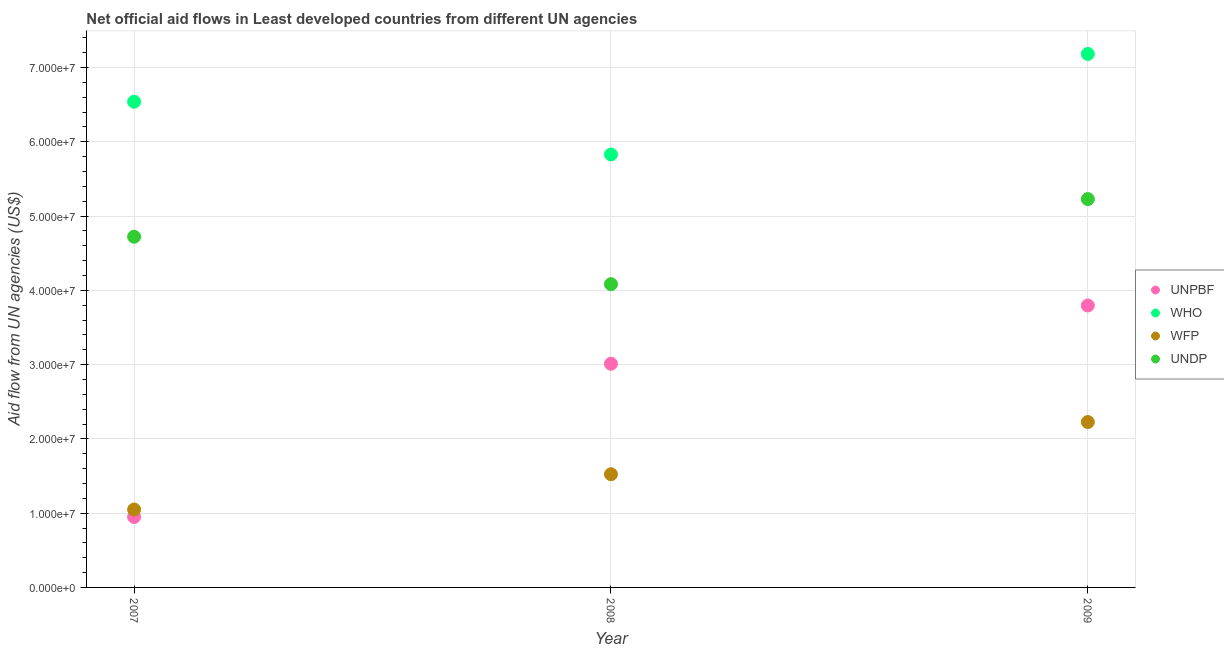Is the number of dotlines equal to the number of legend labels?
Give a very brief answer. Yes. What is the amount of aid given by undp in 2007?
Offer a terse response. 4.72e+07. Across all years, what is the maximum amount of aid given by undp?
Your response must be concise. 5.23e+07. Across all years, what is the minimum amount of aid given by undp?
Your answer should be very brief. 4.08e+07. In which year was the amount of aid given by unpbf maximum?
Ensure brevity in your answer.  2009. In which year was the amount of aid given by unpbf minimum?
Offer a very short reply. 2007. What is the total amount of aid given by wfp in the graph?
Your response must be concise. 4.80e+07. What is the difference between the amount of aid given by undp in 2007 and that in 2009?
Provide a succinct answer. -5.07e+06. What is the difference between the amount of aid given by who in 2007 and the amount of aid given by wfp in 2008?
Your answer should be very brief. 5.02e+07. What is the average amount of aid given by unpbf per year?
Provide a succinct answer. 2.59e+07. In the year 2009, what is the difference between the amount of aid given by wfp and amount of aid given by undp?
Offer a terse response. -3.00e+07. What is the ratio of the amount of aid given by who in 2007 to that in 2008?
Keep it short and to the point. 1.12. Is the difference between the amount of aid given by who in 2007 and 2009 greater than the difference between the amount of aid given by unpbf in 2007 and 2009?
Keep it short and to the point. Yes. What is the difference between the highest and the second highest amount of aid given by unpbf?
Provide a short and direct response. 7.84e+06. What is the difference between the highest and the lowest amount of aid given by wfp?
Offer a very short reply. 1.18e+07. In how many years, is the amount of aid given by who greater than the average amount of aid given by who taken over all years?
Your response must be concise. 2. Is the sum of the amount of aid given by wfp in 2008 and 2009 greater than the maximum amount of aid given by undp across all years?
Your answer should be compact. No. Is it the case that in every year, the sum of the amount of aid given by unpbf and amount of aid given by undp is greater than the sum of amount of aid given by who and amount of aid given by wfp?
Offer a terse response. Yes. How many dotlines are there?
Keep it short and to the point. 4. Are the values on the major ticks of Y-axis written in scientific E-notation?
Your response must be concise. Yes. Does the graph contain any zero values?
Your response must be concise. No. Does the graph contain grids?
Offer a very short reply. Yes. How are the legend labels stacked?
Your answer should be very brief. Vertical. What is the title of the graph?
Keep it short and to the point. Net official aid flows in Least developed countries from different UN agencies. What is the label or title of the Y-axis?
Provide a succinct answer. Aid flow from UN agencies (US$). What is the Aid flow from UN agencies (US$) in UNPBF in 2007?
Give a very brief answer. 9.49e+06. What is the Aid flow from UN agencies (US$) in WHO in 2007?
Provide a short and direct response. 6.54e+07. What is the Aid flow from UN agencies (US$) in WFP in 2007?
Provide a short and direct response. 1.05e+07. What is the Aid flow from UN agencies (US$) of UNDP in 2007?
Offer a very short reply. 4.72e+07. What is the Aid flow from UN agencies (US$) of UNPBF in 2008?
Ensure brevity in your answer.  3.01e+07. What is the Aid flow from UN agencies (US$) of WHO in 2008?
Offer a terse response. 5.83e+07. What is the Aid flow from UN agencies (US$) of WFP in 2008?
Your answer should be very brief. 1.52e+07. What is the Aid flow from UN agencies (US$) in UNDP in 2008?
Offer a terse response. 4.08e+07. What is the Aid flow from UN agencies (US$) of UNPBF in 2009?
Give a very brief answer. 3.80e+07. What is the Aid flow from UN agencies (US$) of WHO in 2009?
Your answer should be very brief. 7.18e+07. What is the Aid flow from UN agencies (US$) in WFP in 2009?
Keep it short and to the point. 2.23e+07. What is the Aid flow from UN agencies (US$) of UNDP in 2009?
Keep it short and to the point. 5.23e+07. Across all years, what is the maximum Aid flow from UN agencies (US$) in UNPBF?
Provide a short and direct response. 3.80e+07. Across all years, what is the maximum Aid flow from UN agencies (US$) of WHO?
Ensure brevity in your answer.  7.18e+07. Across all years, what is the maximum Aid flow from UN agencies (US$) of WFP?
Keep it short and to the point. 2.23e+07. Across all years, what is the maximum Aid flow from UN agencies (US$) in UNDP?
Offer a very short reply. 5.23e+07. Across all years, what is the minimum Aid flow from UN agencies (US$) of UNPBF?
Provide a short and direct response. 9.49e+06. Across all years, what is the minimum Aid flow from UN agencies (US$) in WHO?
Your answer should be very brief. 5.83e+07. Across all years, what is the minimum Aid flow from UN agencies (US$) in WFP?
Your response must be concise. 1.05e+07. Across all years, what is the minimum Aid flow from UN agencies (US$) of UNDP?
Your answer should be very brief. 4.08e+07. What is the total Aid flow from UN agencies (US$) of UNPBF in the graph?
Make the answer very short. 7.76e+07. What is the total Aid flow from UN agencies (US$) in WHO in the graph?
Offer a very short reply. 1.96e+08. What is the total Aid flow from UN agencies (US$) in WFP in the graph?
Your response must be concise. 4.80e+07. What is the total Aid flow from UN agencies (US$) in UNDP in the graph?
Your response must be concise. 1.40e+08. What is the difference between the Aid flow from UN agencies (US$) in UNPBF in 2007 and that in 2008?
Ensure brevity in your answer.  -2.06e+07. What is the difference between the Aid flow from UN agencies (US$) of WHO in 2007 and that in 2008?
Provide a succinct answer. 7.10e+06. What is the difference between the Aid flow from UN agencies (US$) of WFP in 2007 and that in 2008?
Your answer should be compact. -4.75e+06. What is the difference between the Aid flow from UN agencies (US$) of UNDP in 2007 and that in 2008?
Your answer should be compact. 6.39e+06. What is the difference between the Aid flow from UN agencies (US$) in UNPBF in 2007 and that in 2009?
Provide a short and direct response. -2.85e+07. What is the difference between the Aid flow from UN agencies (US$) of WHO in 2007 and that in 2009?
Make the answer very short. -6.43e+06. What is the difference between the Aid flow from UN agencies (US$) in WFP in 2007 and that in 2009?
Give a very brief answer. -1.18e+07. What is the difference between the Aid flow from UN agencies (US$) in UNDP in 2007 and that in 2009?
Offer a terse response. -5.07e+06. What is the difference between the Aid flow from UN agencies (US$) in UNPBF in 2008 and that in 2009?
Give a very brief answer. -7.84e+06. What is the difference between the Aid flow from UN agencies (US$) of WHO in 2008 and that in 2009?
Provide a short and direct response. -1.35e+07. What is the difference between the Aid flow from UN agencies (US$) of WFP in 2008 and that in 2009?
Make the answer very short. -7.03e+06. What is the difference between the Aid flow from UN agencies (US$) in UNDP in 2008 and that in 2009?
Provide a succinct answer. -1.15e+07. What is the difference between the Aid flow from UN agencies (US$) in UNPBF in 2007 and the Aid flow from UN agencies (US$) in WHO in 2008?
Provide a short and direct response. -4.88e+07. What is the difference between the Aid flow from UN agencies (US$) of UNPBF in 2007 and the Aid flow from UN agencies (US$) of WFP in 2008?
Your answer should be compact. -5.75e+06. What is the difference between the Aid flow from UN agencies (US$) in UNPBF in 2007 and the Aid flow from UN agencies (US$) in UNDP in 2008?
Your answer should be very brief. -3.13e+07. What is the difference between the Aid flow from UN agencies (US$) of WHO in 2007 and the Aid flow from UN agencies (US$) of WFP in 2008?
Your answer should be very brief. 5.02e+07. What is the difference between the Aid flow from UN agencies (US$) in WHO in 2007 and the Aid flow from UN agencies (US$) in UNDP in 2008?
Your answer should be very brief. 2.46e+07. What is the difference between the Aid flow from UN agencies (US$) of WFP in 2007 and the Aid flow from UN agencies (US$) of UNDP in 2008?
Your response must be concise. -3.03e+07. What is the difference between the Aid flow from UN agencies (US$) of UNPBF in 2007 and the Aid flow from UN agencies (US$) of WHO in 2009?
Give a very brief answer. -6.23e+07. What is the difference between the Aid flow from UN agencies (US$) in UNPBF in 2007 and the Aid flow from UN agencies (US$) in WFP in 2009?
Give a very brief answer. -1.28e+07. What is the difference between the Aid flow from UN agencies (US$) in UNPBF in 2007 and the Aid flow from UN agencies (US$) in UNDP in 2009?
Your answer should be compact. -4.28e+07. What is the difference between the Aid flow from UN agencies (US$) of WHO in 2007 and the Aid flow from UN agencies (US$) of WFP in 2009?
Provide a succinct answer. 4.31e+07. What is the difference between the Aid flow from UN agencies (US$) in WHO in 2007 and the Aid flow from UN agencies (US$) in UNDP in 2009?
Keep it short and to the point. 1.31e+07. What is the difference between the Aid flow from UN agencies (US$) in WFP in 2007 and the Aid flow from UN agencies (US$) in UNDP in 2009?
Your answer should be compact. -4.18e+07. What is the difference between the Aid flow from UN agencies (US$) of UNPBF in 2008 and the Aid flow from UN agencies (US$) of WHO in 2009?
Make the answer very short. -4.17e+07. What is the difference between the Aid flow from UN agencies (US$) of UNPBF in 2008 and the Aid flow from UN agencies (US$) of WFP in 2009?
Give a very brief answer. 7.85e+06. What is the difference between the Aid flow from UN agencies (US$) of UNPBF in 2008 and the Aid flow from UN agencies (US$) of UNDP in 2009?
Your response must be concise. -2.22e+07. What is the difference between the Aid flow from UN agencies (US$) in WHO in 2008 and the Aid flow from UN agencies (US$) in WFP in 2009?
Ensure brevity in your answer.  3.60e+07. What is the difference between the Aid flow from UN agencies (US$) of WHO in 2008 and the Aid flow from UN agencies (US$) of UNDP in 2009?
Make the answer very short. 6.01e+06. What is the difference between the Aid flow from UN agencies (US$) in WFP in 2008 and the Aid flow from UN agencies (US$) in UNDP in 2009?
Your answer should be compact. -3.70e+07. What is the average Aid flow from UN agencies (US$) in UNPBF per year?
Give a very brief answer. 2.59e+07. What is the average Aid flow from UN agencies (US$) of WHO per year?
Provide a succinct answer. 6.52e+07. What is the average Aid flow from UN agencies (US$) in WFP per year?
Provide a succinct answer. 1.60e+07. What is the average Aid flow from UN agencies (US$) in UNDP per year?
Offer a terse response. 4.68e+07. In the year 2007, what is the difference between the Aid flow from UN agencies (US$) of UNPBF and Aid flow from UN agencies (US$) of WHO?
Ensure brevity in your answer.  -5.59e+07. In the year 2007, what is the difference between the Aid flow from UN agencies (US$) in UNPBF and Aid flow from UN agencies (US$) in UNDP?
Your response must be concise. -3.77e+07. In the year 2007, what is the difference between the Aid flow from UN agencies (US$) of WHO and Aid flow from UN agencies (US$) of WFP?
Keep it short and to the point. 5.49e+07. In the year 2007, what is the difference between the Aid flow from UN agencies (US$) of WHO and Aid flow from UN agencies (US$) of UNDP?
Keep it short and to the point. 1.82e+07. In the year 2007, what is the difference between the Aid flow from UN agencies (US$) in WFP and Aid flow from UN agencies (US$) in UNDP?
Your answer should be compact. -3.67e+07. In the year 2008, what is the difference between the Aid flow from UN agencies (US$) in UNPBF and Aid flow from UN agencies (US$) in WHO?
Offer a terse response. -2.82e+07. In the year 2008, what is the difference between the Aid flow from UN agencies (US$) of UNPBF and Aid flow from UN agencies (US$) of WFP?
Give a very brief answer. 1.49e+07. In the year 2008, what is the difference between the Aid flow from UN agencies (US$) in UNPBF and Aid flow from UN agencies (US$) in UNDP?
Provide a short and direct response. -1.07e+07. In the year 2008, what is the difference between the Aid flow from UN agencies (US$) in WHO and Aid flow from UN agencies (US$) in WFP?
Your answer should be compact. 4.31e+07. In the year 2008, what is the difference between the Aid flow from UN agencies (US$) in WHO and Aid flow from UN agencies (US$) in UNDP?
Your answer should be very brief. 1.75e+07. In the year 2008, what is the difference between the Aid flow from UN agencies (US$) of WFP and Aid flow from UN agencies (US$) of UNDP?
Give a very brief answer. -2.56e+07. In the year 2009, what is the difference between the Aid flow from UN agencies (US$) in UNPBF and Aid flow from UN agencies (US$) in WHO?
Provide a short and direct response. -3.39e+07. In the year 2009, what is the difference between the Aid flow from UN agencies (US$) of UNPBF and Aid flow from UN agencies (US$) of WFP?
Give a very brief answer. 1.57e+07. In the year 2009, what is the difference between the Aid flow from UN agencies (US$) of UNPBF and Aid flow from UN agencies (US$) of UNDP?
Provide a succinct answer. -1.43e+07. In the year 2009, what is the difference between the Aid flow from UN agencies (US$) of WHO and Aid flow from UN agencies (US$) of WFP?
Make the answer very short. 4.96e+07. In the year 2009, what is the difference between the Aid flow from UN agencies (US$) of WHO and Aid flow from UN agencies (US$) of UNDP?
Your answer should be compact. 1.95e+07. In the year 2009, what is the difference between the Aid flow from UN agencies (US$) in WFP and Aid flow from UN agencies (US$) in UNDP?
Offer a terse response. -3.00e+07. What is the ratio of the Aid flow from UN agencies (US$) of UNPBF in 2007 to that in 2008?
Keep it short and to the point. 0.32. What is the ratio of the Aid flow from UN agencies (US$) of WHO in 2007 to that in 2008?
Offer a very short reply. 1.12. What is the ratio of the Aid flow from UN agencies (US$) in WFP in 2007 to that in 2008?
Offer a terse response. 0.69. What is the ratio of the Aid flow from UN agencies (US$) of UNDP in 2007 to that in 2008?
Offer a very short reply. 1.16. What is the ratio of the Aid flow from UN agencies (US$) in UNPBF in 2007 to that in 2009?
Your response must be concise. 0.25. What is the ratio of the Aid flow from UN agencies (US$) of WHO in 2007 to that in 2009?
Make the answer very short. 0.91. What is the ratio of the Aid flow from UN agencies (US$) of WFP in 2007 to that in 2009?
Offer a very short reply. 0.47. What is the ratio of the Aid flow from UN agencies (US$) of UNDP in 2007 to that in 2009?
Give a very brief answer. 0.9. What is the ratio of the Aid flow from UN agencies (US$) of UNPBF in 2008 to that in 2009?
Offer a very short reply. 0.79. What is the ratio of the Aid flow from UN agencies (US$) of WHO in 2008 to that in 2009?
Provide a succinct answer. 0.81. What is the ratio of the Aid flow from UN agencies (US$) in WFP in 2008 to that in 2009?
Your answer should be very brief. 0.68. What is the ratio of the Aid flow from UN agencies (US$) in UNDP in 2008 to that in 2009?
Provide a succinct answer. 0.78. What is the difference between the highest and the second highest Aid flow from UN agencies (US$) of UNPBF?
Keep it short and to the point. 7.84e+06. What is the difference between the highest and the second highest Aid flow from UN agencies (US$) of WHO?
Ensure brevity in your answer.  6.43e+06. What is the difference between the highest and the second highest Aid flow from UN agencies (US$) of WFP?
Give a very brief answer. 7.03e+06. What is the difference between the highest and the second highest Aid flow from UN agencies (US$) of UNDP?
Give a very brief answer. 5.07e+06. What is the difference between the highest and the lowest Aid flow from UN agencies (US$) of UNPBF?
Provide a short and direct response. 2.85e+07. What is the difference between the highest and the lowest Aid flow from UN agencies (US$) of WHO?
Make the answer very short. 1.35e+07. What is the difference between the highest and the lowest Aid flow from UN agencies (US$) in WFP?
Ensure brevity in your answer.  1.18e+07. What is the difference between the highest and the lowest Aid flow from UN agencies (US$) of UNDP?
Ensure brevity in your answer.  1.15e+07. 